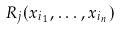Convert formula to latex. <formula><loc_0><loc_0><loc_500><loc_500>R _ { j } ( x _ { i _ { 1 } } , \dots , x _ { i _ { n } } )</formula> 